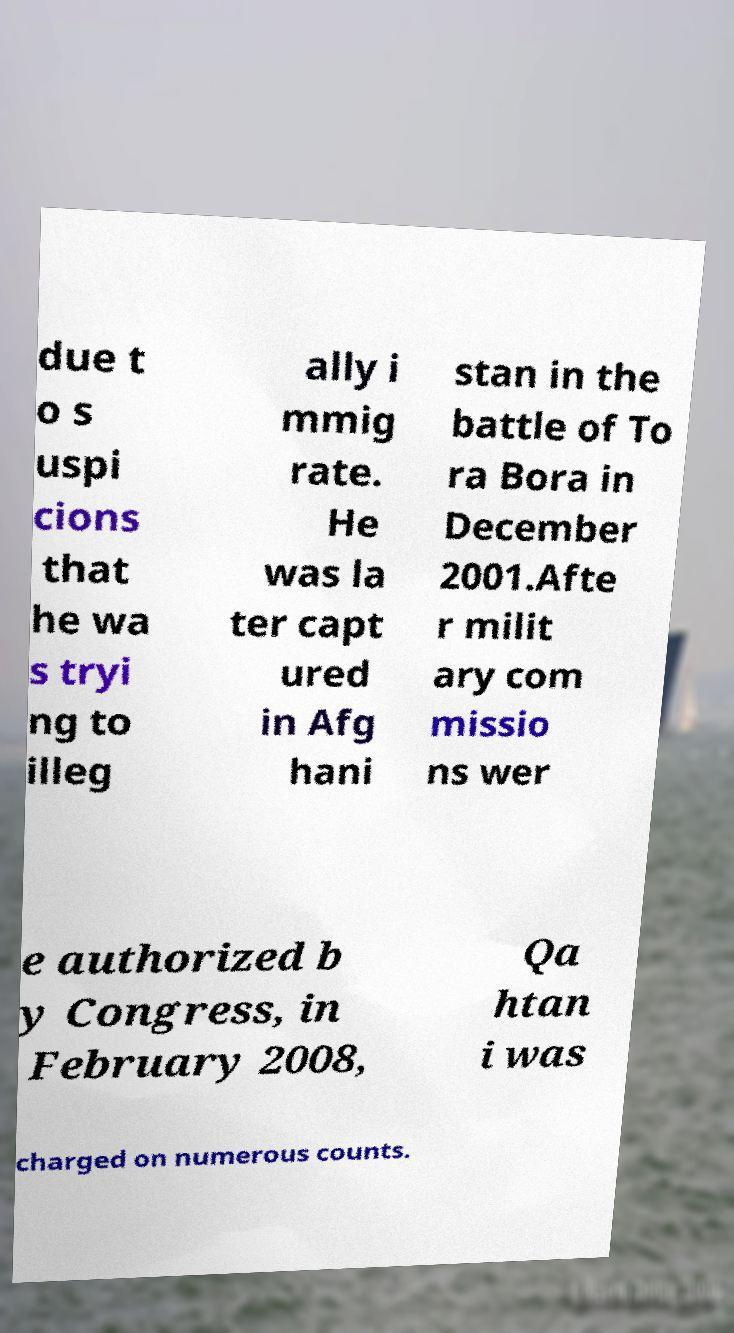Please read and relay the text visible in this image. What does it say? due t o s uspi cions that he wa s tryi ng to illeg ally i mmig rate. He was la ter capt ured in Afg hani stan in the battle of To ra Bora in December 2001.Afte r milit ary com missio ns wer e authorized b y Congress, in February 2008, Qa htan i was charged on numerous counts. 